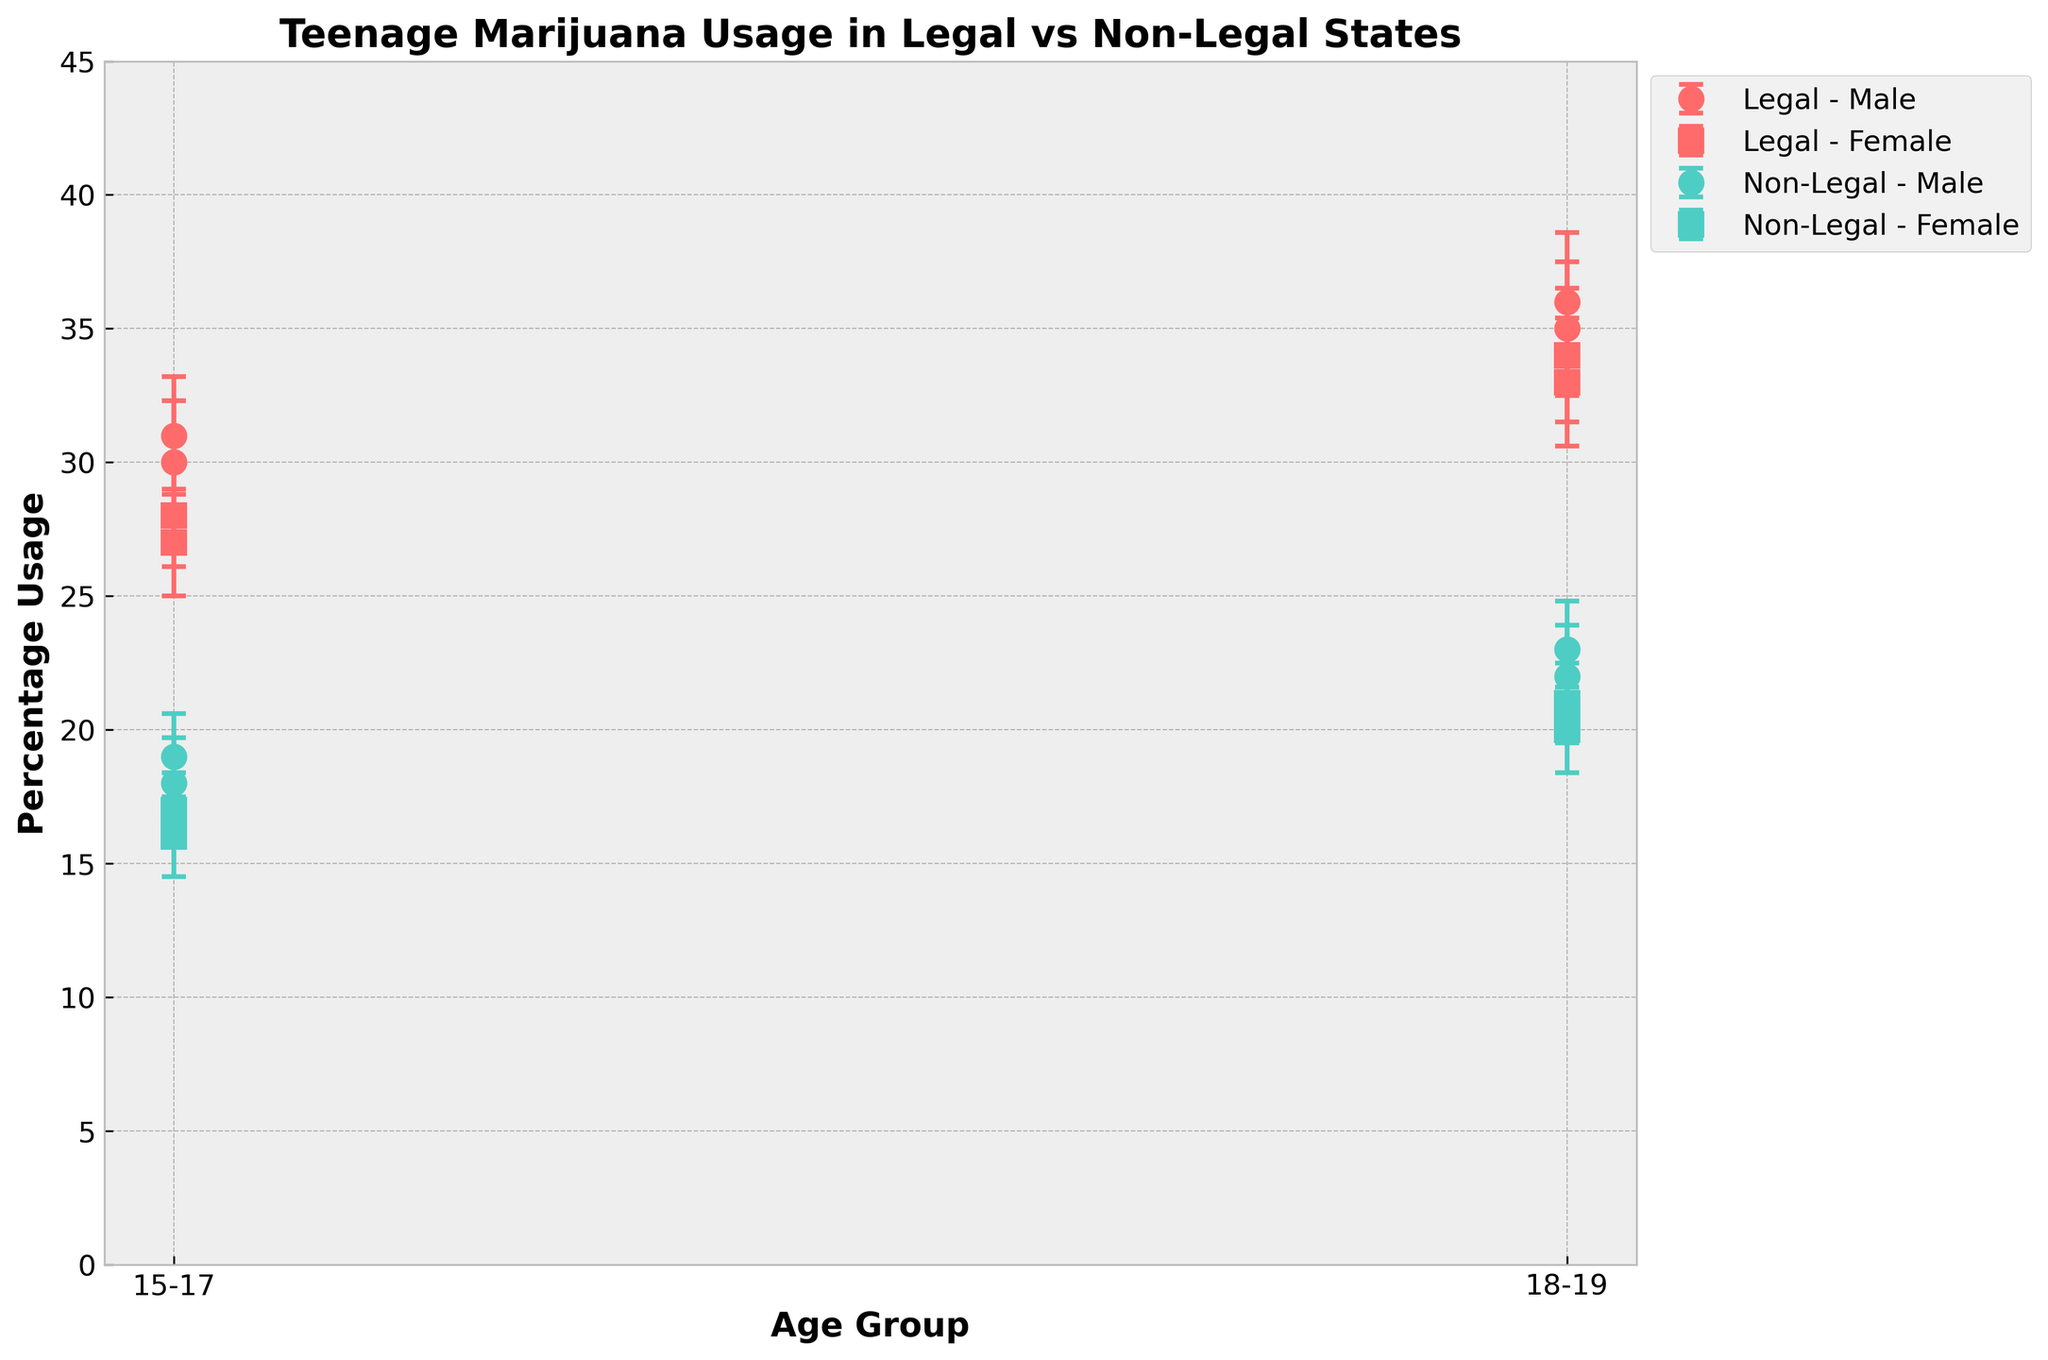What is the title of the figure? The title is typically displayed at the top of the figure and summarizes the main topic. The title helps quickly understand the subject of the plot.
Answer: Teenage Marijuana Usage in Legal vs Non-Legal States Which age group has the highest percentage usage in Colorado? To determine this, look at the percentage usage values for both males and females in the age groups 15-17 and 18-19 for Colorado. The highest percentage usage is the one that stands out.
Answer: 18-19 What is the difference in percentage usage between males and females aged 15-17 in Texas? Find the percentage usage for males and females in Texas who are aged 15-17. Subtract the female percentage from the male percentage. For Texas, it is 18% for males and 16% for females, so the difference is 18 - 16.
Answer: 2% How does the percentage usage of teenagers in non-legal states compare to legal states for the 18-19 age group? Compare the percentage usage values of both males and females aged 18-19 across legal states (Colorado, Washington) and non-legal states (Texas, Florida). In legal states, males have 35-36% and females have 33-34%, while in non-legal states, males have 22-23% and females have 20-21%.
Answer: Higher in legal states Which gender has more variation in percentage usage in 18-19 age group in Washington? Analyze the error bars for both males and females in Washington. The gender with the larger error bars has more variation. Here, error bars for males are slightly larger (2.6) compared to females (2.5).
Answer: Males What is the range of percentage usage for 15-17 age group across all states? Identify the lowest and highest percentage usage values for the 15-17 age group across all states. The lowest is 16% (Texas females) and the highest is 31% (Washington males). The range is 31 - 16.
Answer: 15% Is the percentage usage higher for males or females aged 18-19 in Florida? Check the percentage usage for both males and females aged 18-19 in Florida. Males have 23% usage, while females have 21%. Compare these values.
Answer: Males Does any gender in non-legal states show higher percentage usage compared to their counterpart in legal states for the 15-17 age group? Compare the percentage usage of males and females in non-legal states with their counterparts in legal states for the 15-17 age group. Males and females in non-legal states (18%, 16% in Texas; 19%, 17% in Florida) are consistently lower than those in legal states (30%, 28% in Colorado; 31%, 27% in Washington).
Answer: No 